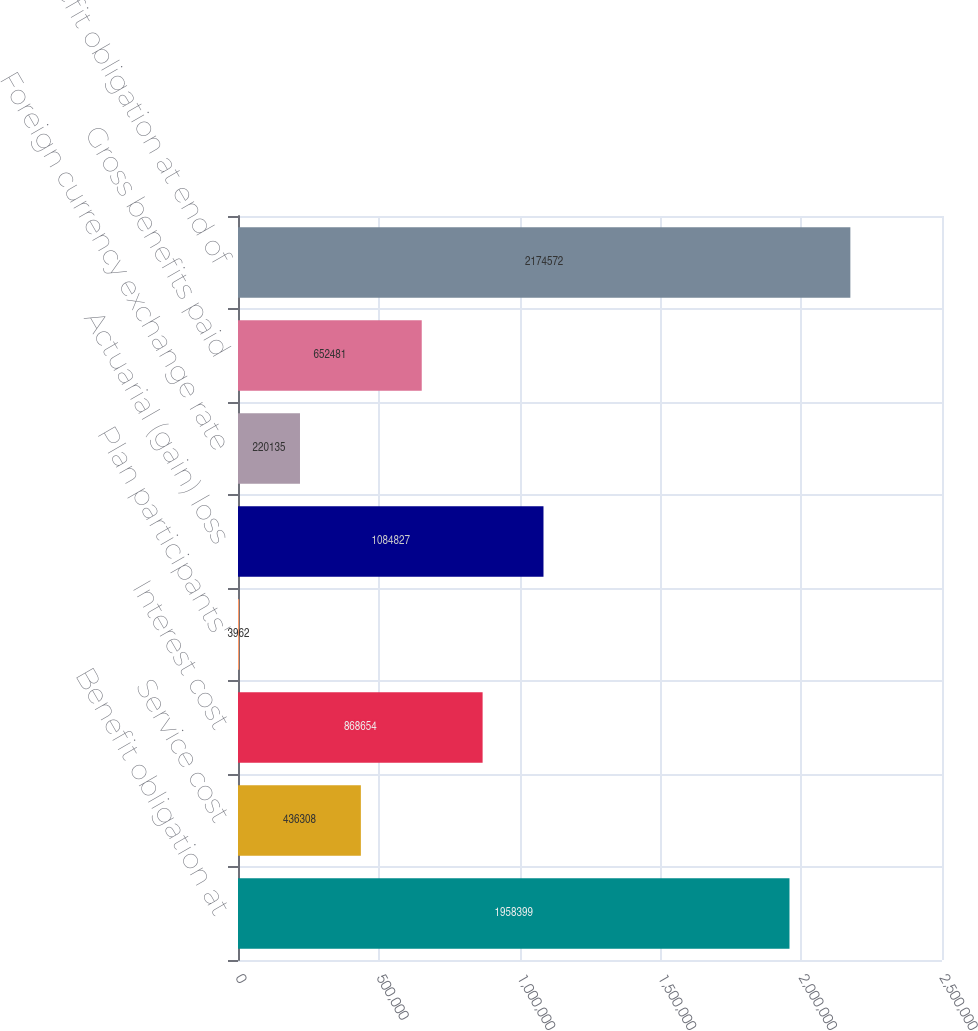<chart> <loc_0><loc_0><loc_500><loc_500><bar_chart><fcel>Benefit obligation at<fcel>Service cost<fcel>Interest cost<fcel>Plan participants'<fcel>Actuarial (gain) loss<fcel>Foreign currency exchange rate<fcel>Gross benefits paid<fcel>Benefit obligation at end of<nl><fcel>1.9584e+06<fcel>436308<fcel>868654<fcel>3962<fcel>1.08483e+06<fcel>220135<fcel>652481<fcel>2.17457e+06<nl></chart> 